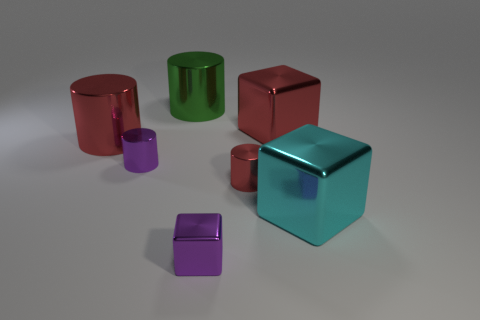Add 3 tiny shiny cubes. How many objects exist? 10 Subtract all blocks. How many objects are left? 4 Subtract all small purple cylinders. Subtract all purple cubes. How many objects are left? 5 Add 6 tiny metallic cubes. How many tiny metallic cubes are left? 7 Add 5 red cubes. How many red cubes exist? 6 Subtract 1 cyan blocks. How many objects are left? 6 